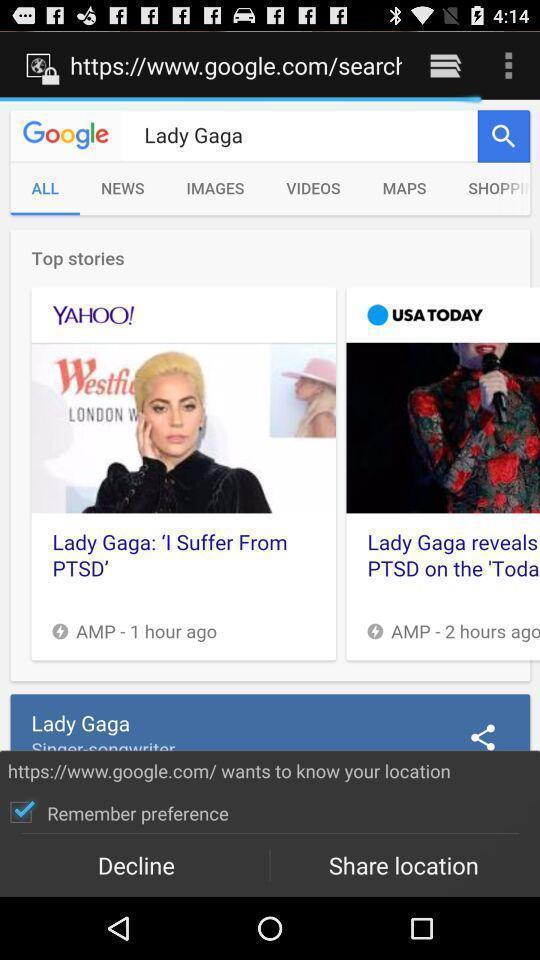Tell me about the visual elements in this screen capture. Page displaying the information about a artist. 